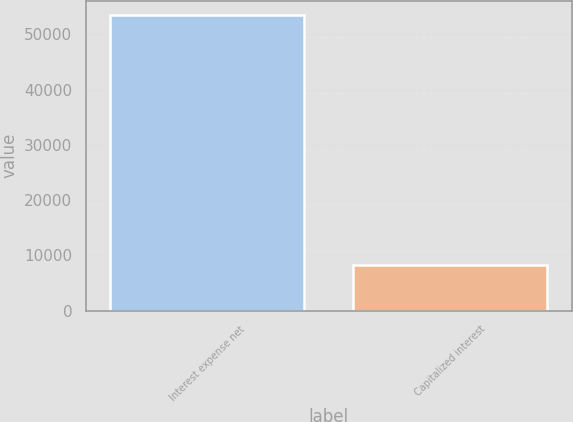<chart> <loc_0><loc_0><loc_500><loc_500><bar_chart><fcel>Interest expense net<fcel>Capitalized interest<nl><fcel>53460<fcel>8168<nl></chart> 